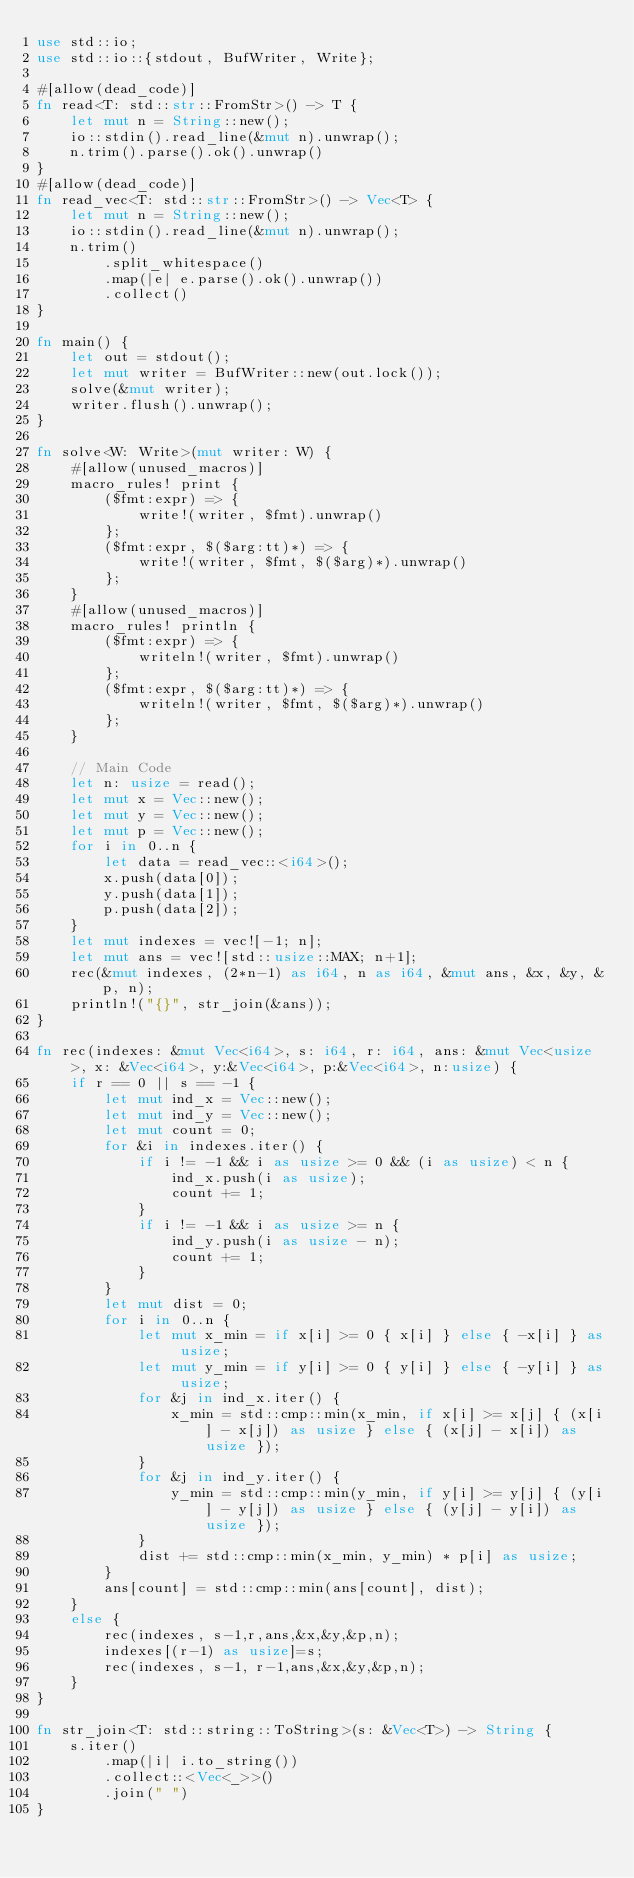<code> <loc_0><loc_0><loc_500><loc_500><_Rust_>use std::io;
use std::io::{stdout, BufWriter, Write};

#[allow(dead_code)]
fn read<T: std::str::FromStr>() -> T {
    let mut n = String::new();
    io::stdin().read_line(&mut n).unwrap();
    n.trim().parse().ok().unwrap()
}
#[allow(dead_code)]
fn read_vec<T: std::str::FromStr>() -> Vec<T> {
    let mut n = String::new();
    io::stdin().read_line(&mut n).unwrap();
    n.trim()
        .split_whitespace()
        .map(|e| e.parse().ok().unwrap())
        .collect()
}

fn main() {
    let out = stdout();
    let mut writer = BufWriter::new(out.lock());
    solve(&mut writer);
    writer.flush().unwrap();
}

fn solve<W: Write>(mut writer: W) {
    #[allow(unused_macros)]
    macro_rules! print {
        ($fmt:expr) => {
            write!(writer, $fmt).unwrap()
        };
        ($fmt:expr, $($arg:tt)*) => {
            write!(writer, $fmt, $($arg)*).unwrap()
        };
    }
    #[allow(unused_macros)]
    macro_rules! println {
        ($fmt:expr) => {
            writeln!(writer, $fmt).unwrap()
        };
        ($fmt:expr, $($arg:tt)*) => {
            writeln!(writer, $fmt, $($arg)*).unwrap()
        };
    }

    // Main Code
    let n: usize = read();
    let mut x = Vec::new();
    let mut y = Vec::new();
    let mut p = Vec::new();
    for i in 0..n {
        let data = read_vec::<i64>();
        x.push(data[0]);
        y.push(data[1]);
        p.push(data[2]);
    }
    let mut indexes = vec![-1; n];
    let mut ans = vec![std::usize::MAX; n+1];
    rec(&mut indexes, (2*n-1) as i64, n as i64, &mut ans, &x, &y, &p, n);
    println!("{}", str_join(&ans));
}

fn rec(indexes: &mut Vec<i64>, s: i64, r: i64, ans: &mut Vec<usize>, x: &Vec<i64>, y:&Vec<i64>, p:&Vec<i64>, n:usize) {
    if r == 0 || s == -1 {
        let mut ind_x = Vec::new();
        let mut ind_y = Vec::new();
        let mut count = 0;
        for &i in indexes.iter() {
            if i != -1 && i as usize >= 0 && (i as usize) < n {
                ind_x.push(i as usize);
                count += 1;
            }
            if i != -1 && i as usize >= n {
                ind_y.push(i as usize - n);
                count += 1;
            }
        }
        let mut dist = 0;
        for i in 0..n {
            let mut x_min = if x[i] >= 0 { x[i] } else { -x[i] } as usize;
            let mut y_min = if y[i] >= 0 { y[i] } else { -y[i] } as usize;
            for &j in ind_x.iter() {
                x_min = std::cmp::min(x_min, if x[i] >= x[j] { (x[i] - x[j]) as usize } else { (x[j] - x[i]) as usize });
            }
            for &j in ind_y.iter() {
                y_min = std::cmp::min(y_min, if y[i] >= y[j] { (y[i] - y[j]) as usize } else { (y[j] - y[i]) as usize });
            }
            dist += std::cmp::min(x_min, y_min) * p[i] as usize;
        }
        ans[count] = std::cmp::min(ans[count], dist);
    }
    else {
        rec(indexes, s-1,r,ans,&x,&y,&p,n);
        indexes[(r-1) as usize]=s;
        rec(indexes, s-1, r-1,ans,&x,&y,&p,n);
    }
}

fn str_join<T: std::string::ToString>(s: &Vec<T>) -> String {
    s.iter()
        .map(|i| i.to_string())
        .collect::<Vec<_>>()
        .join(" ")
}
</code> 